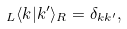Convert formula to latex. <formula><loc_0><loc_0><loc_500><loc_500>_ { L } \langle k | k ^ { \prime } \rangle _ { R } = \delta _ { k k ^ { \prime } } ,</formula> 